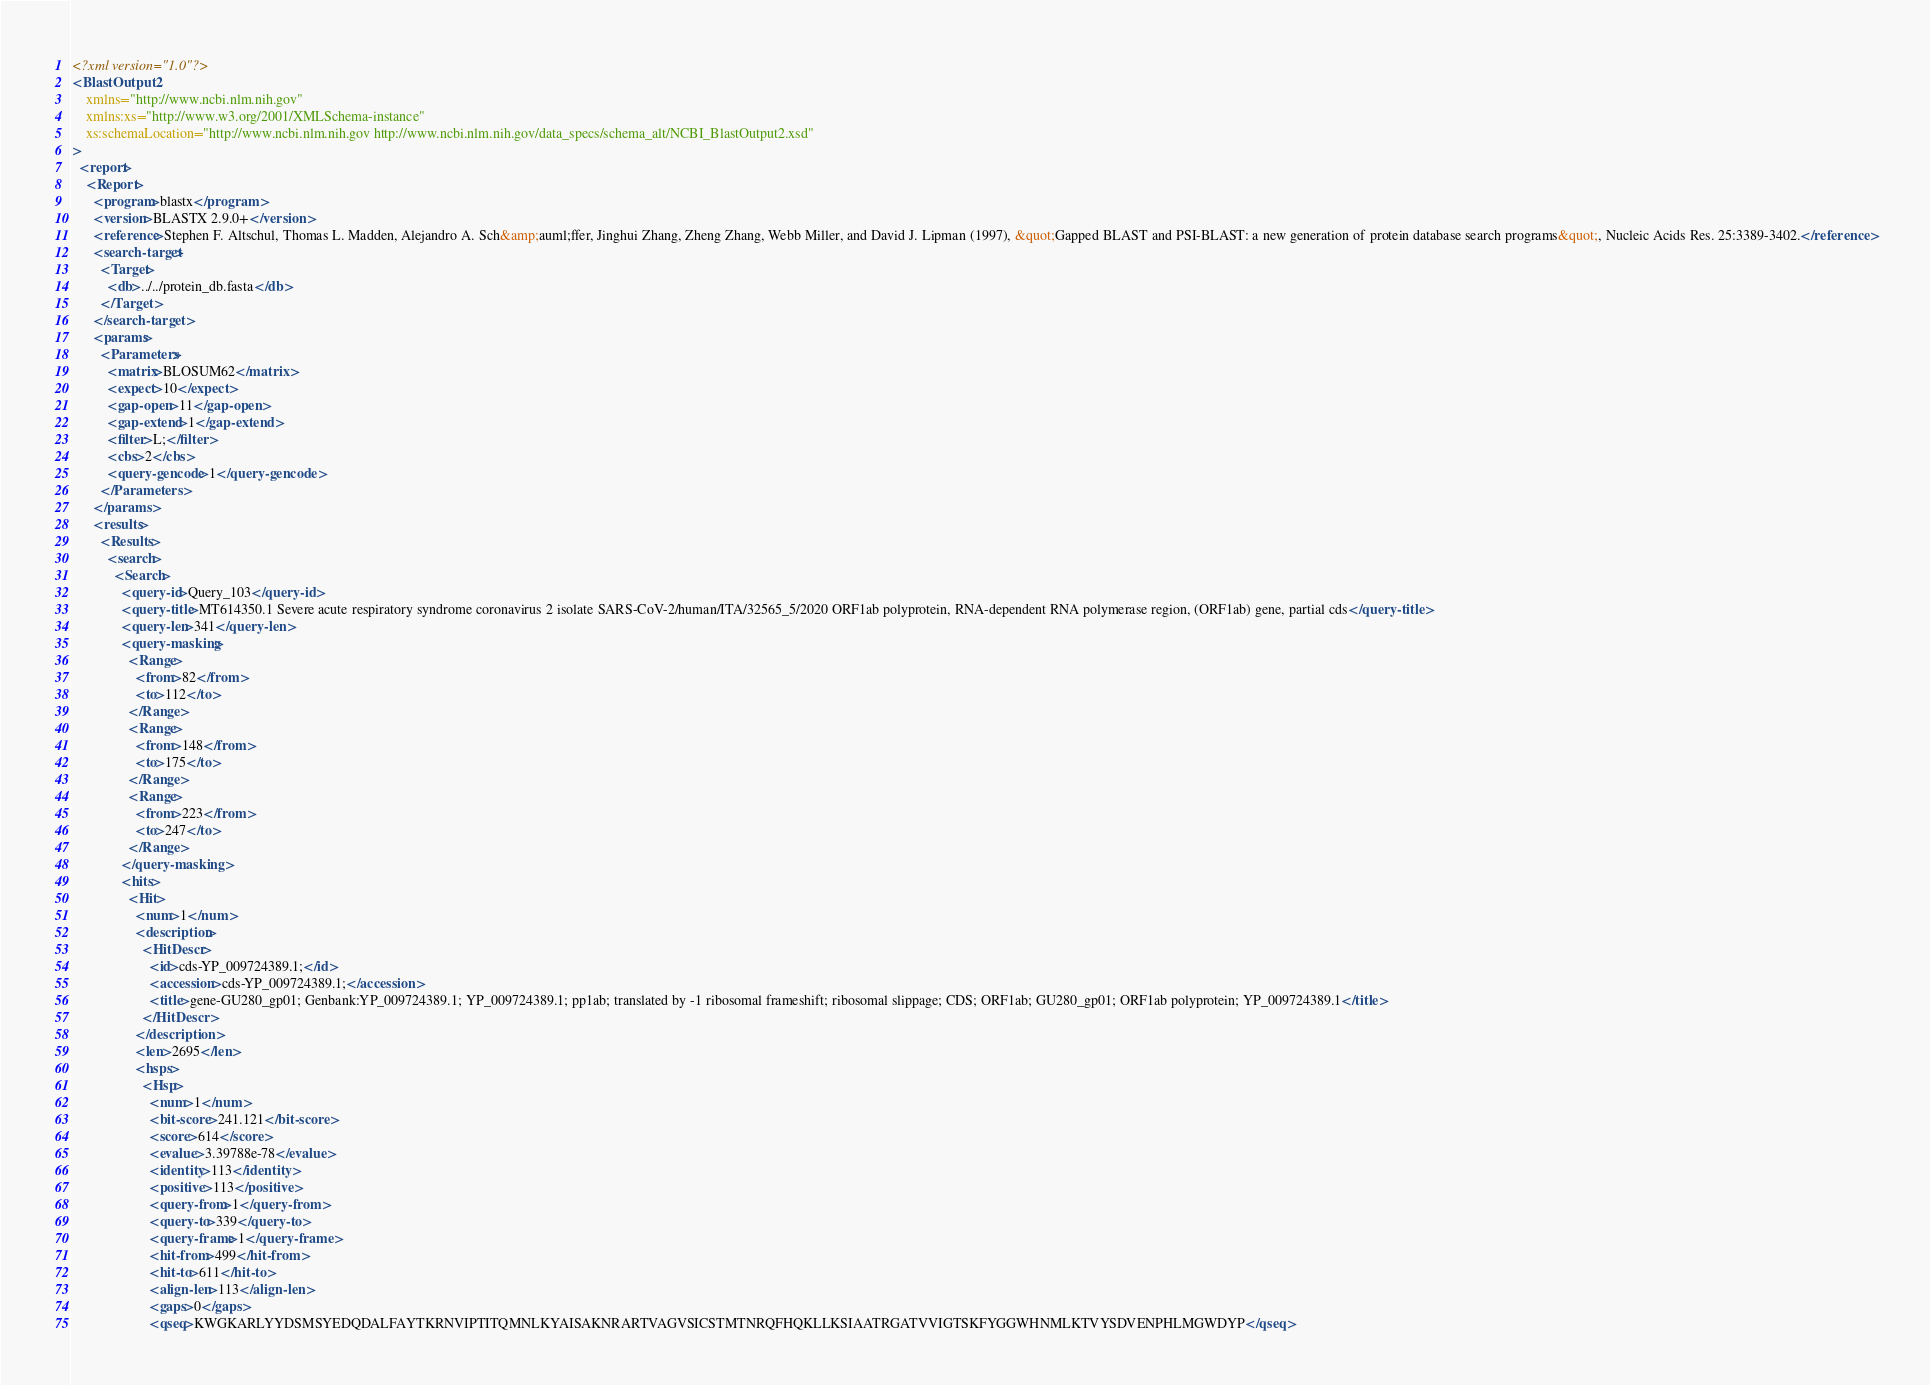<code> <loc_0><loc_0><loc_500><loc_500><_XML_><?xml version="1.0"?>
<BlastOutput2
    xmlns="http://www.ncbi.nlm.nih.gov"
    xmlns:xs="http://www.w3.org/2001/XMLSchema-instance"
    xs:schemaLocation="http://www.ncbi.nlm.nih.gov http://www.ncbi.nlm.nih.gov/data_specs/schema_alt/NCBI_BlastOutput2.xsd"
>
  <report>
    <Report>
      <program>blastx</program>
      <version>BLASTX 2.9.0+</version>
      <reference>Stephen F. Altschul, Thomas L. Madden, Alejandro A. Sch&amp;auml;ffer, Jinghui Zhang, Zheng Zhang, Webb Miller, and David J. Lipman (1997), &quot;Gapped BLAST and PSI-BLAST: a new generation of protein database search programs&quot;, Nucleic Acids Res. 25:3389-3402.</reference>
      <search-target>
        <Target>
          <db>../../protein_db.fasta</db>
        </Target>
      </search-target>
      <params>
        <Parameters>
          <matrix>BLOSUM62</matrix>
          <expect>10</expect>
          <gap-open>11</gap-open>
          <gap-extend>1</gap-extend>
          <filter>L;</filter>
          <cbs>2</cbs>
          <query-gencode>1</query-gencode>
        </Parameters>
      </params>
      <results>
        <Results>
          <search>
            <Search>
              <query-id>Query_103</query-id>
              <query-title>MT614350.1 Severe acute respiratory syndrome coronavirus 2 isolate SARS-CoV-2/human/ITA/32565_5/2020 ORF1ab polyprotein, RNA-dependent RNA polymerase region, (ORF1ab) gene, partial cds</query-title>
              <query-len>341</query-len>
              <query-masking>
                <Range>
                  <from>82</from>
                  <to>112</to>
                </Range>
                <Range>
                  <from>148</from>
                  <to>175</to>
                </Range>
                <Range>
                  <from>223</from>
                  <to>247</to>
                </Range>
              </query-masking>
              <hits>
                <Hit>
                  <num>1</num>
                  <description>
                    <HitDescr>
                      <id>cds-YP_009724389.1;</id>
                      <accession>cds-YP_009724389.1;</accession>
                      <title>gene-GU280_gp01; Genbank:YP_009724389.1; YP_009724389.1; pp1ab; translated by -1 ribosomal frameshift; ribosomal slippage; CDS; ORF1ab; GU280_gp01; ORF1ab polyprotein; YP_009724389.1</title>
                    </HitDescr>
                  </description>
                  <len>2695</len>
                  <hsps>
                    <Hsp>
                      <num>1</num>
                      <bit-score>241.121</bit-score>
                      <score>614</score>
                      <evalue>3.39788e-78</evalue>
                      <identity>113</identity>
                      <positive>113</positive>
                      <query-from>1</query-from>
                      <query-to>339</query-to>
                      <query-frame>1</query-frame>
                      <hit-from>499</hit-from>
                      <hit-to>611</hit-to>
                      <align-len>113</align-len>
                      <gaps>0</gaps>
                      <qseq>KWGKARLYYDSMSYEDQDALFAYTKRNVIPTITQMNLKYAISAKNRARTVAGVSICSTMTNRQFHQKLLKSIAATRGATVVIGTSKFYGGWHNMLKTVYSDVENPHLMGWDYP</qseq></code> 